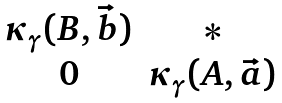<formula> <loc_0><loc_0><loc_500><loc_500>\begin{matrix} \kappa _ { \gamma } ( B , \vec { b } ) & * \\ 0 & \kappa _ { \gamma } ( A , \vec { a } ) \end{matrix}</formula> 